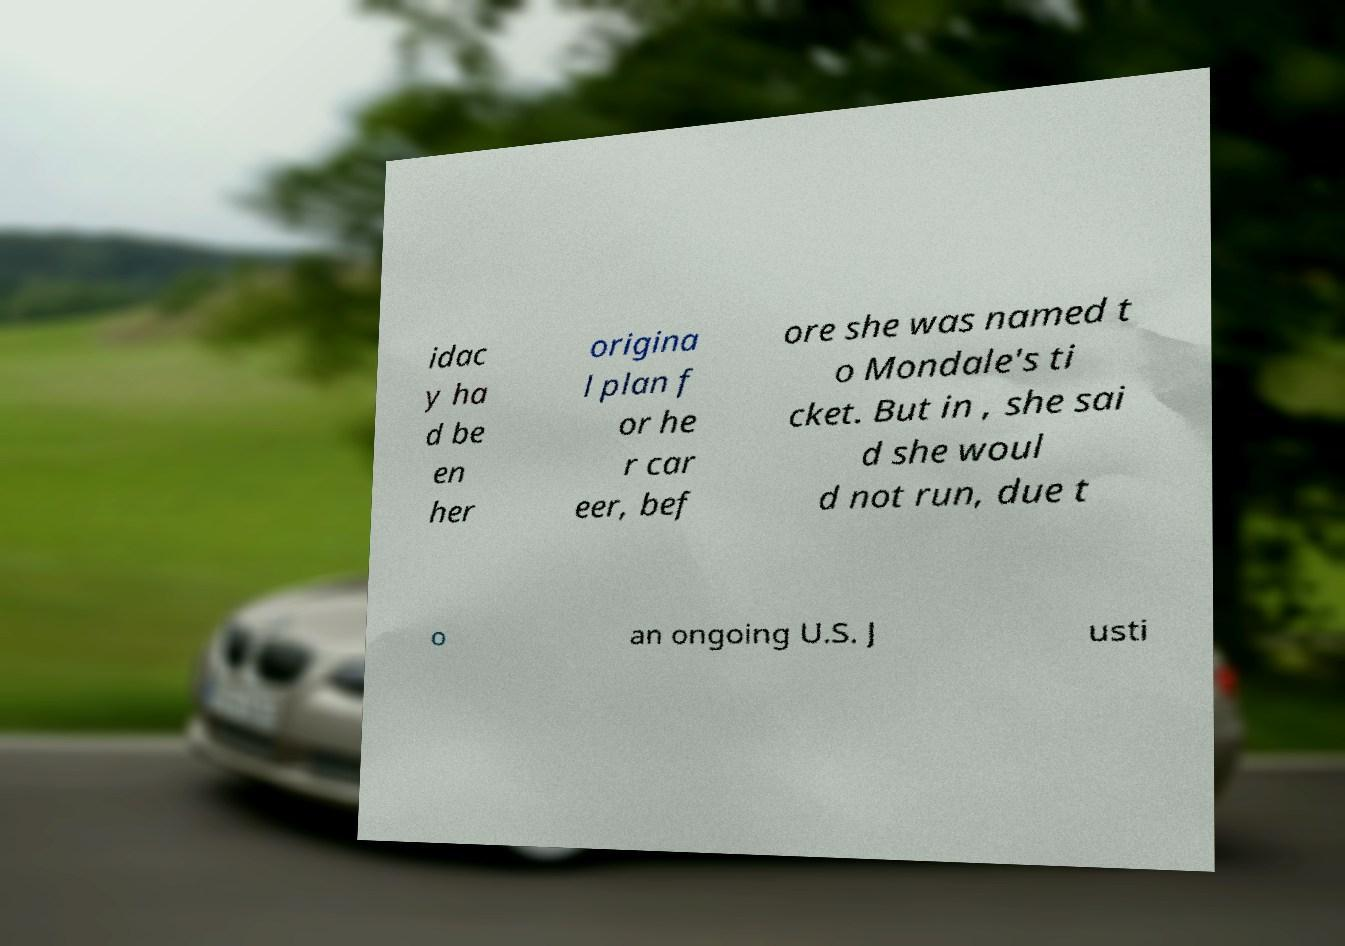What messages or text are displayed in this image? I need them in a readable, typed format. idac y ha d be en her origina l plan f or he r car eer, bef ore she was named t o Mondale's ti cket. But in , she sai d she woul d not run, due t o an ongoing U.S. J usti 